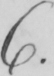What is written in this line of handwriting? 6 . 